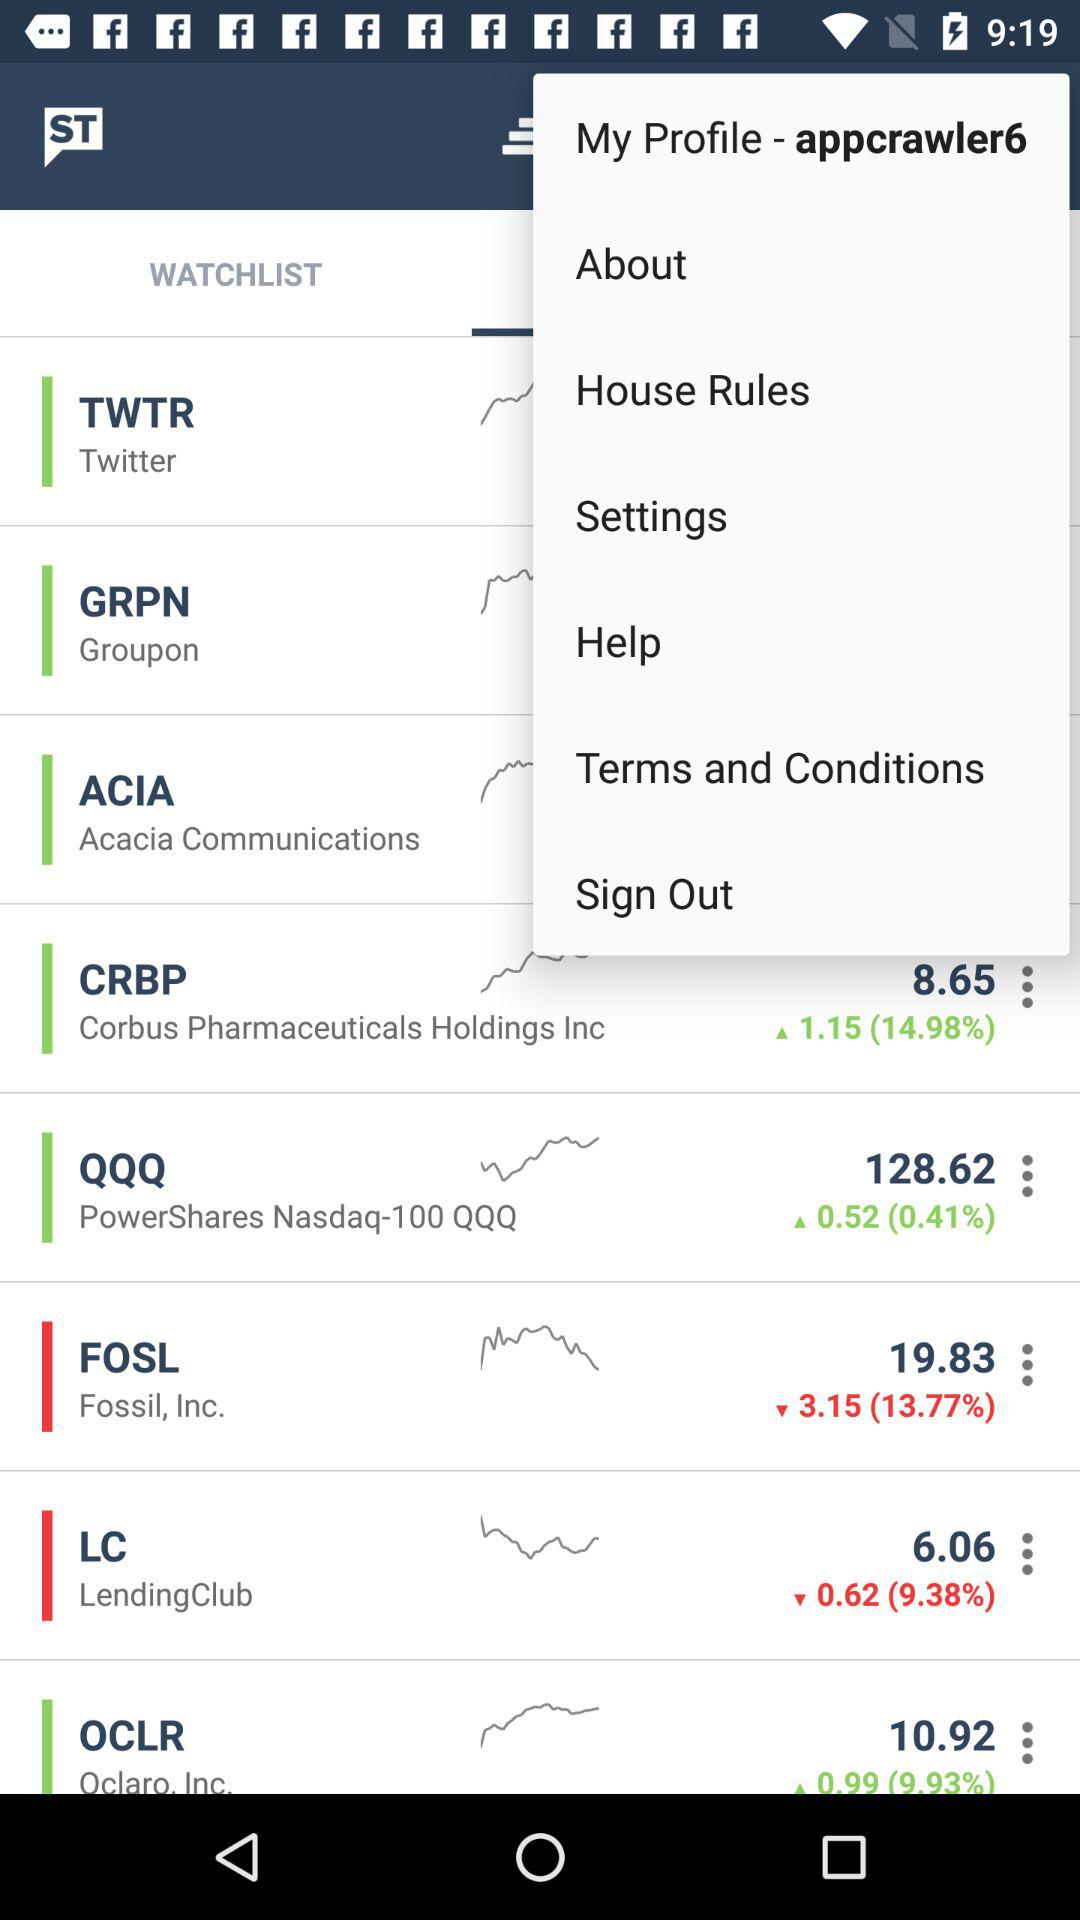What is the profile name? The profile name is "appcrawler6". 